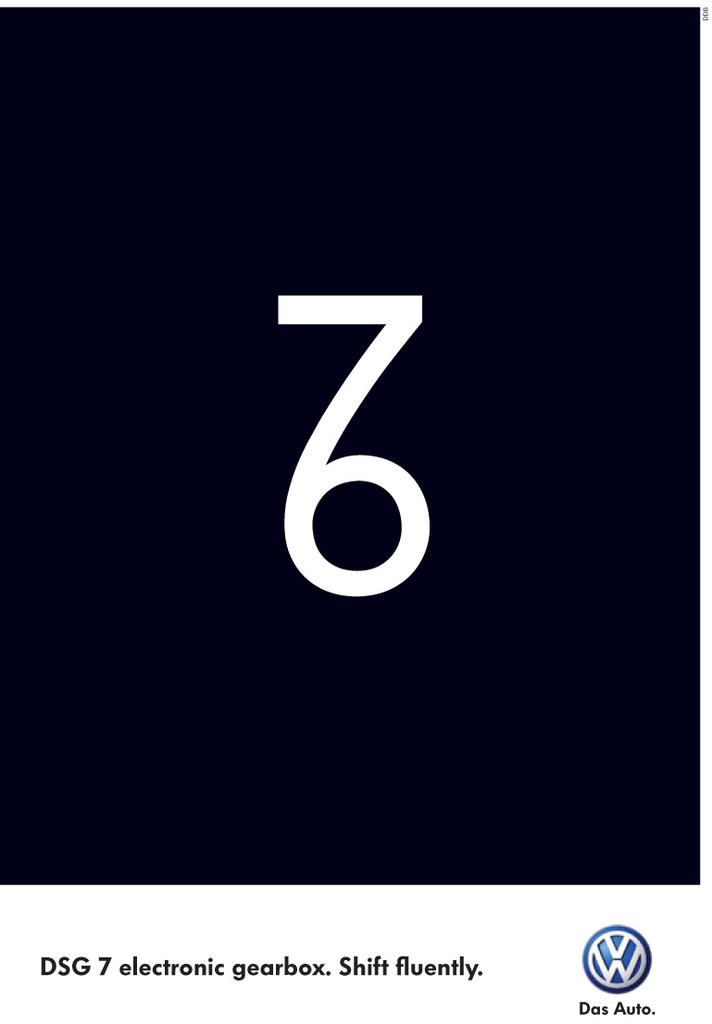<image>
Describe the image concisely. A VW poster with a 7 attached to a 6 to make a weird looking glyph 